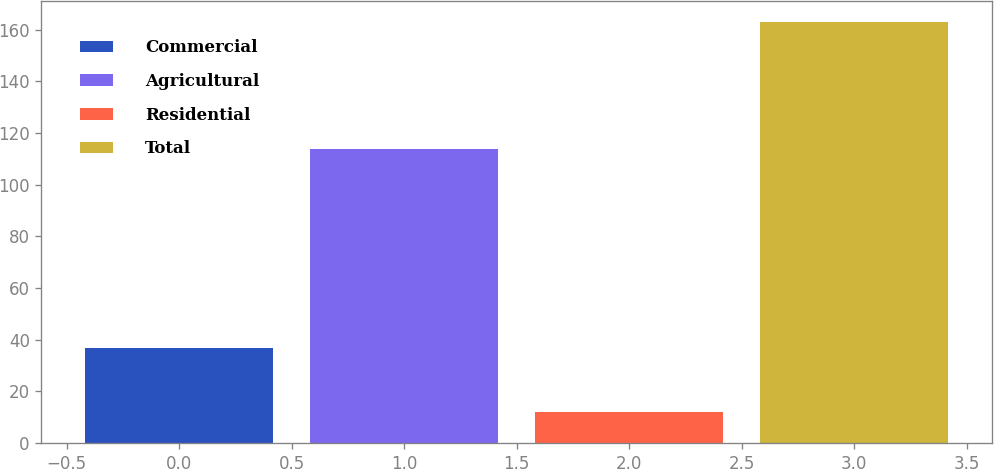<chart> <loc_0><loc_0><loc_500><loc_500><bar_chart><fcel>Commercial<fcel>Agricultural<fcel>Residential<fcel>Total<nl><fcel>37<fcel>114<fcel>12<fcel>163<nl></chart> 